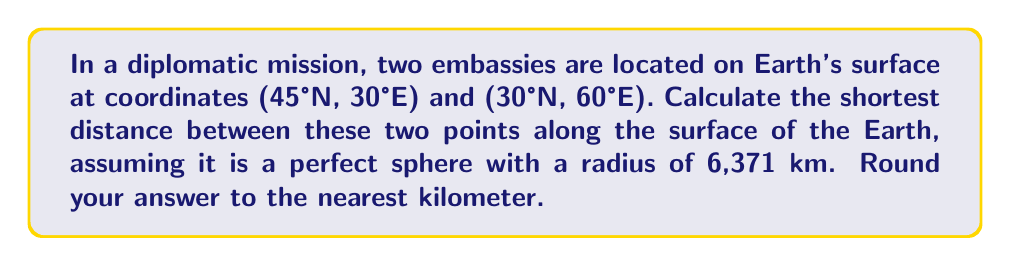Give your solution to this math problem. To solve this problem, we'll use the great circle distance formula, which gives the shortest distance between two points on a spherical surface. The steps are as follows:

1. Convert the given coordinates from degrees to radians:
   $\phi_1 = 45° \cdot \frac{\pi}{180°} = 0.7854$ rad
   $\lambda_1 = 30° \cdot \frac{\pi}{180°} = 0.5236$ rad
   $\phi_2 = 30° \cdot \frac{\pi}{180°} = 0.5236$ rad
   $\lambda_2 = 60° \cdot \frac{\pi}{180°} = 1.0472$ rad

2. Apply the great circle distance formula:
   $$\Delta \sigma = \arccos(\sin\phi_1 \sin\phi_2 + \cos\phi_1 \cos\phi_2 \cos(\Delta\lambda))$$
   
   Where $\Delta\lambda = |\lambda_2 - \lambda_1|$

3. Calculate $\Delta\lambda$:
   $\Delta\lambda = |1.0472 - 0.5236| = 0.5236$ rad

4. Substitute the values into the formula:
   $$\Delta \sigma = \arccos(\sin(0.7854) \sin(0.5236) + \cos(0.7854) \cos(0.5236) \cos(0.5236))$$

5. Evaluate the expression:
   $\Delta \sigma = 0.3979$ rad

6. Calculate the distance by multiplying the angular distance by the Earth's radius:
   $d = R \cdot \Delta \sigma = 6371 \text{ km} \cdot 0.3979 \text{ rad} = 2534.8 \text{ km}$

7. Round to the nearest kilometer:
   $d \approx 2535 \text{ km}$
Answer: 2535 km 